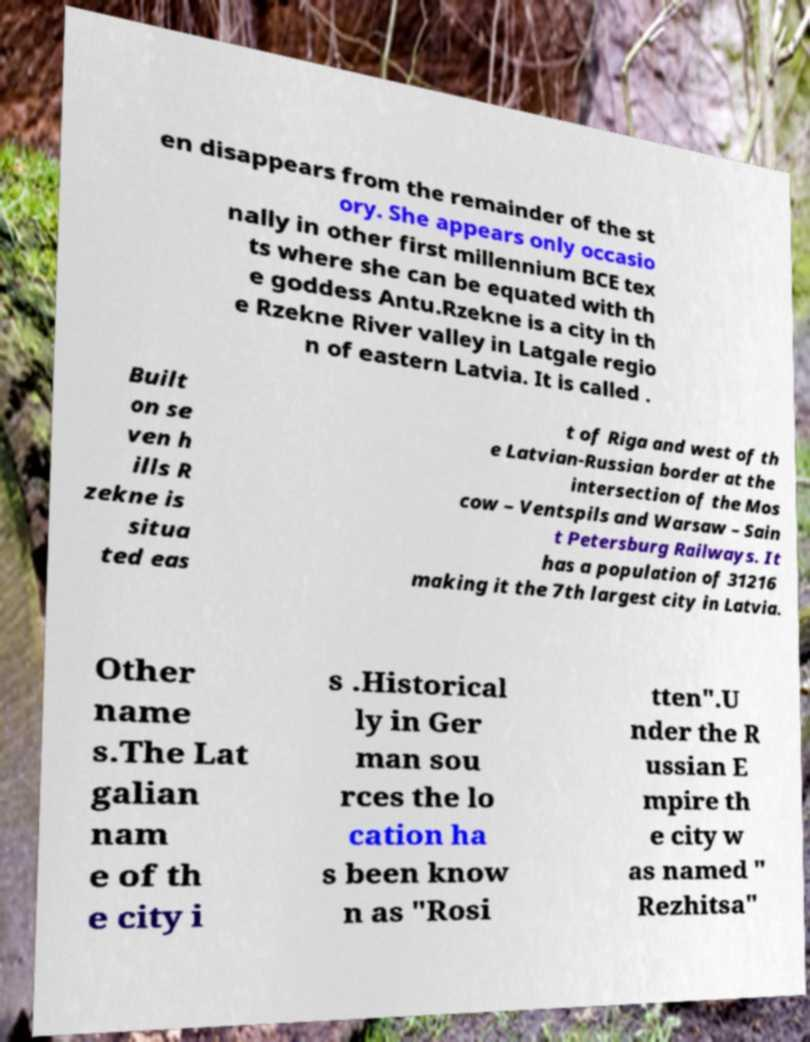There's text embedded in this image that I need extracted. Can you transcribe it verbatim? en disappears from the remainder of the st ory. She appears only occasio nally in other first millennium BCE tex ts where she can be equated with th e goddess Antu.Rzekne is a city in th e Rzekne River valley in Latgale regio n of eastern Latvia. It is called . Built on se ven h ills R zekne is situa ted eas t of Riga and west of th e Latvian-Russian border at the intersection of the Mos cow – Ventspils and Warsaw – Sain t Petersburg Railways. It has a population of 31216 making it the 7th largest city in Latvia. Other name s.The Lat galian nam e of th e city i s .Historical ly in Ger man sou rces the lo cation ha s been know n as "Rosi tten".U nder the R ussian E mpire th e city w as named " Rezhitsa" 